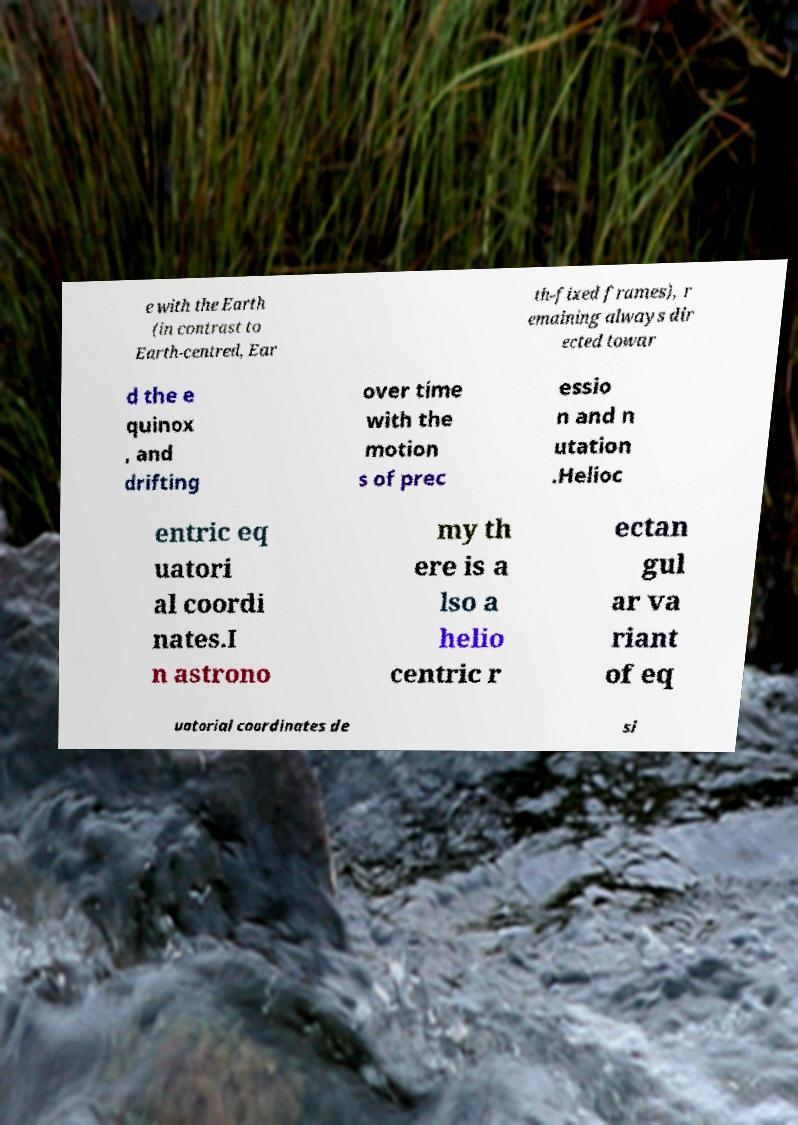Please identify and transcribe the text found in this image. e with the Earth (in contrast to Earth-centred, Ear th-fixed frames), r emaining always dir ected towar d the e quinox , and drifting over time with the motion s of prec essio n and n utation .Helioc entric eq uatori al coordi nates.I n astrono my th ere is a lso a helio centric r ectan gul ar va riant of eq uatorial coordinates de si 